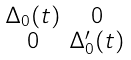<formula> <loc_0><loc_0><loc_500><loc_500>\begin{smallmatrix} \Delta _ { 0 } ( t ) & 0 \\ 0 & \Delta ^ { \prime } _ { 0 } ( t ) \end{smallmatrix}</formula> 